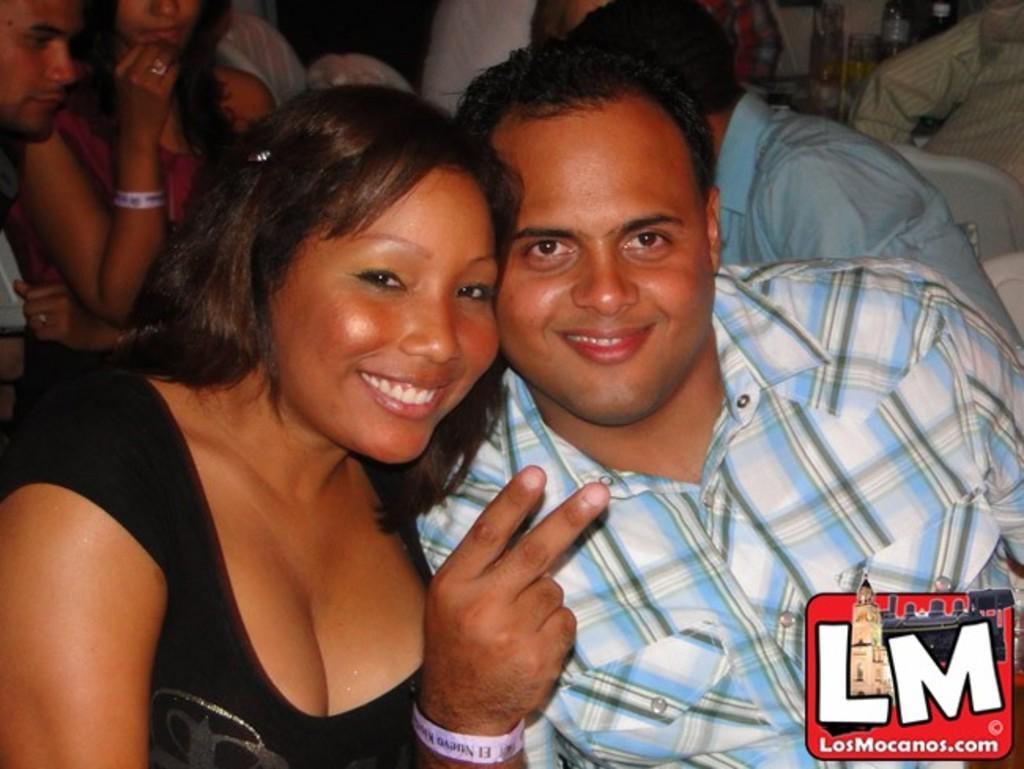Could you give a brief overview of what you see in this image? In this picture I can see a woman and a man in front who are smiling and in the background I see number of people and I see few things on the right of this image and on the bottom right I see the watermark. 